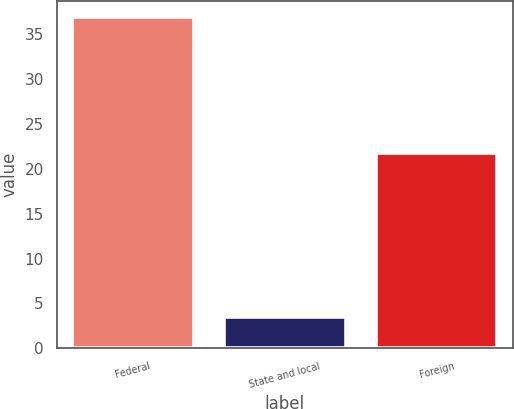<chart> <loc_0><loc_0><loc_500><loc_500><bar_chart><fcel>Federal<fcel>State and local<fcel>Foreign<nl><fcel>36.9<fcel>3.5<fcel>21.8<nl></chart> 